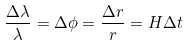<formula> <loc_0><loc_0><loc_500><loc_500>\frac { \Delta \lambda } { \lambda } = \Delta \phi = \frac { \Delta r } { r } = H \Delta t</formula> 